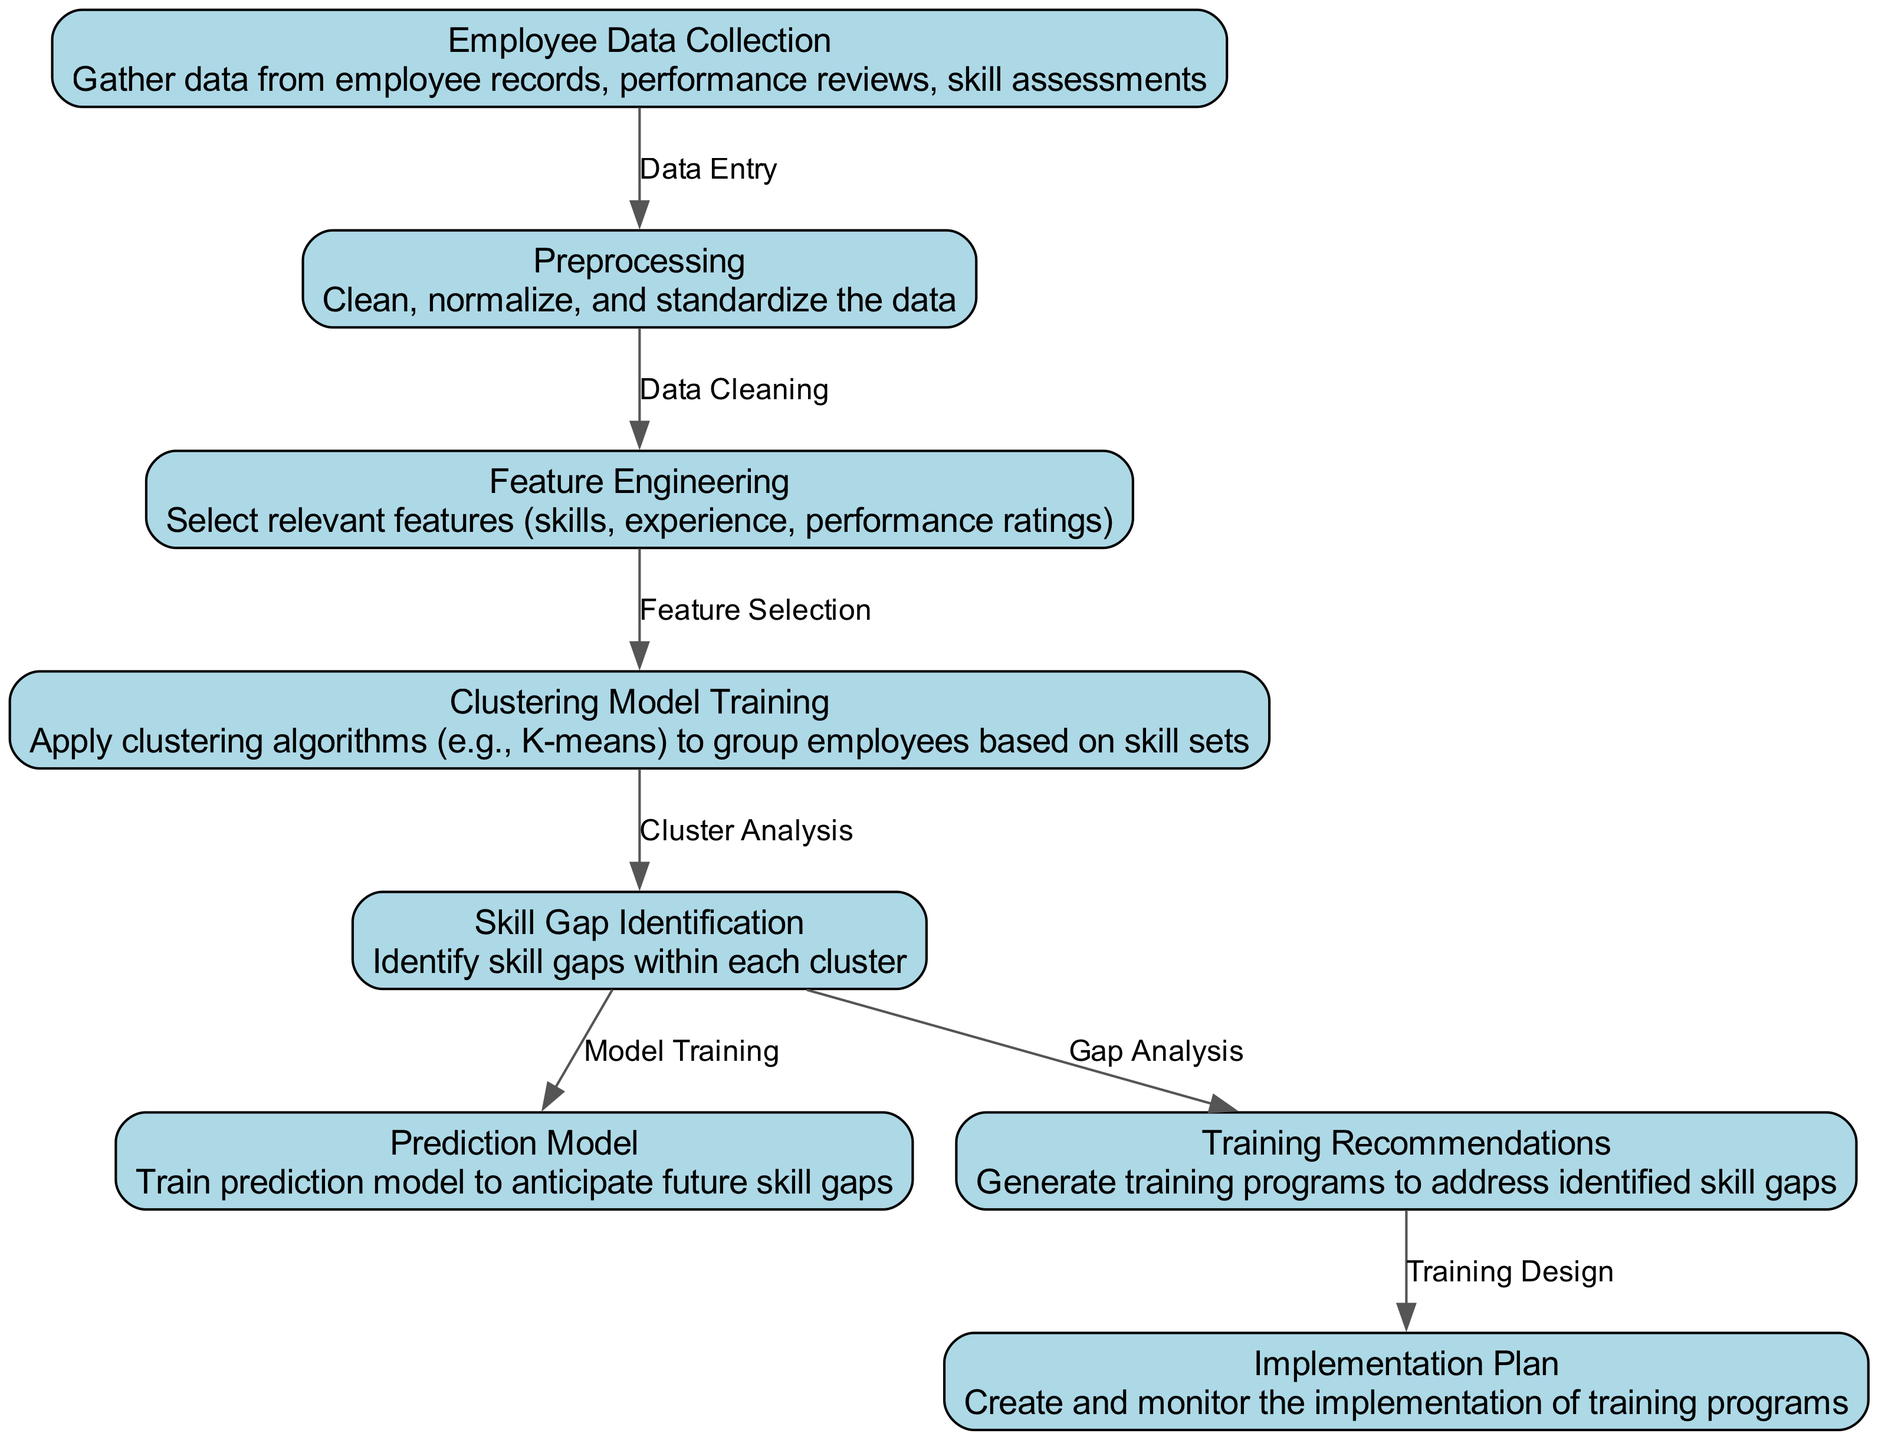What is the first step in the diagram? The diagram begins with "Employee Data Collection," which entails gathering data from various sources related to employee records.
Answer: Employee Data Collection How many total nodes are there in the diagram? By counting the listed nodes, we find there are eight distinct nodes that illustrate different steps in the analysis process.
Answer: Eight What is the label of the node that follows "Preprocessing"? The node that follows "Preprocessing" is "Feature Engineering," which involves selecting relevant features for analysis.
Answer: Feature Engineering What process is performed after "Skill Gap Identification"? Following "Skill Gap Identification," the next process is "Prediction Model," which trains a model to forecast future skill gaps in the workforce.
Answer: Prediction Model Which node is connected to both "Skill Gap Identification" and "Training Recommendations"? The "Skill Gap Identification" node connects to "Prediction Model" and "Training Recommendations," but only the latter provides suggested training programs based on identified gaps.
Answer: Training Recommendations Why is "Clustering Model Training" essential in the analysis? "Clustering Model Training" is crucial as it groups employees based on their skill sets, allowing for better identification of skill gaps within each cluster.
Answer: It groups employees What role does "Implementation Plan" play in the diagram? The "Implementation Plan" is responsible for creating and monitoring the execution of training programs tailored to address skill deficits identified through the analysis.
Answer: Monitor training programs If the diagram started at node three, what would be the previous two steps required? Starting at node three ("Feature Engineering"), the previous two steps encountered would be "Preprocessing" and "Employee Data Collection."
Answer: Employee Data Collection, Preprocessing How does training recommendations relate to skill gap identification? Training recommendations directly relate to skill gap identification as they are generated to address the gaps identified during the analysis process in each employee cluster.
Answer: Address identified skill gaps 